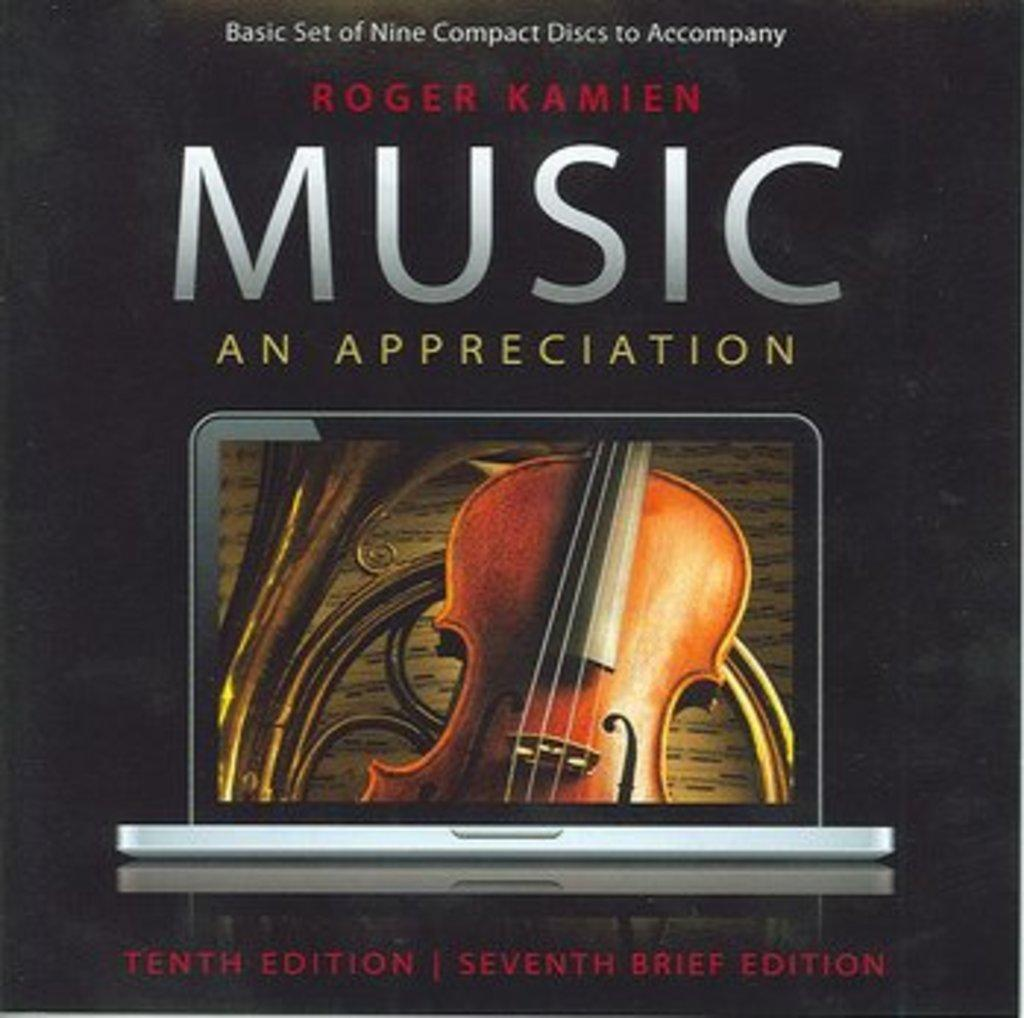<image>
Present a compact description of the photo's key features. A cover reads Music an Appreciation and shows a violin. 